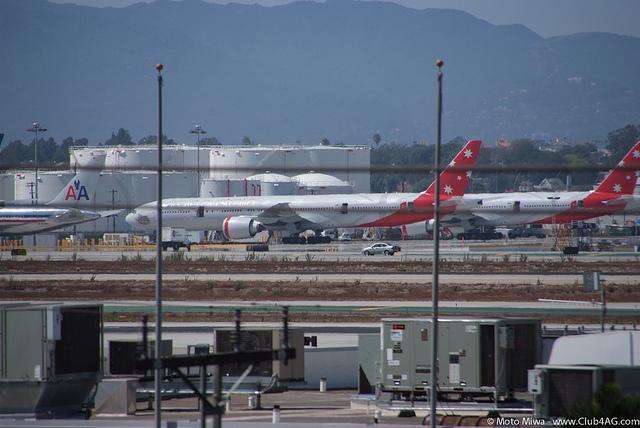How many planes are there?
Give a very brief answer. 3. How many airplanes are in the picture?
Give a very brief answer. 3. How many people are looking at the polar bear?
Give a very brief answer. 0. 